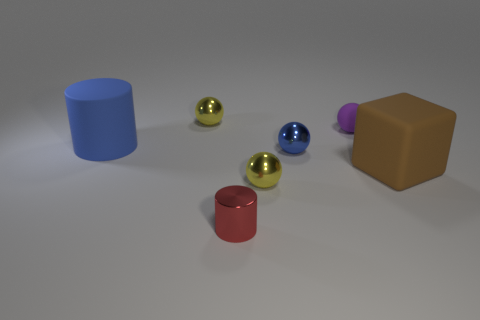Are there any patterns or alignments among the objects in the image? Indeed, the objects are arranged in an approximate diagonal line from the bottom left to the top right of the image, with slight variations in the alignment, adding interest to the composition. 